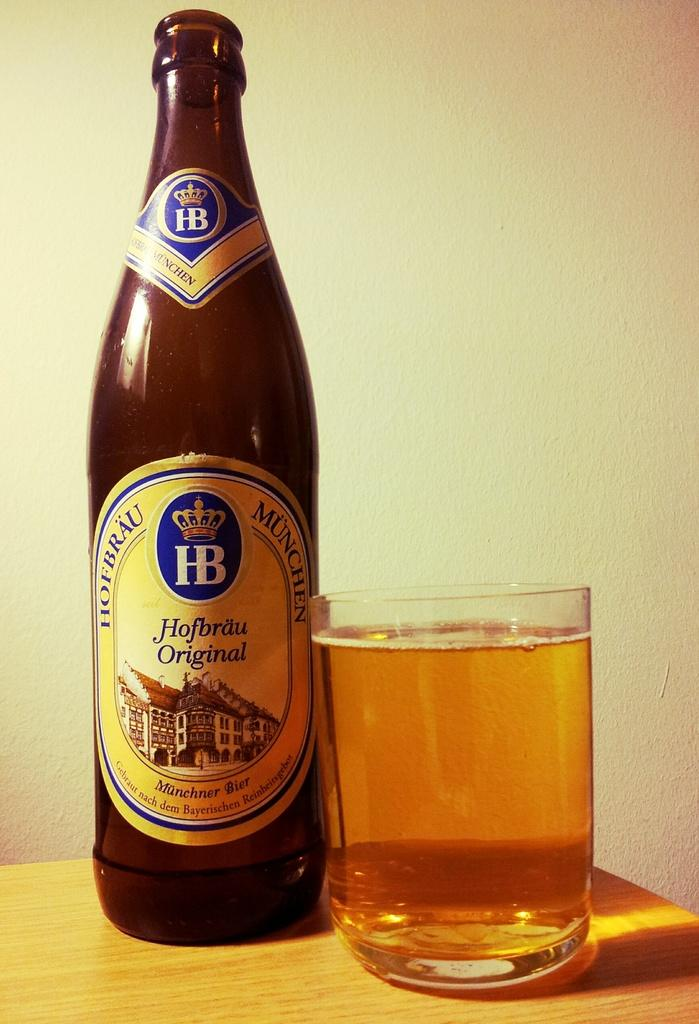<image>
Summarize the visual content of the image. A bottle of Hofbrau Original beer sits next to a short full glass. 